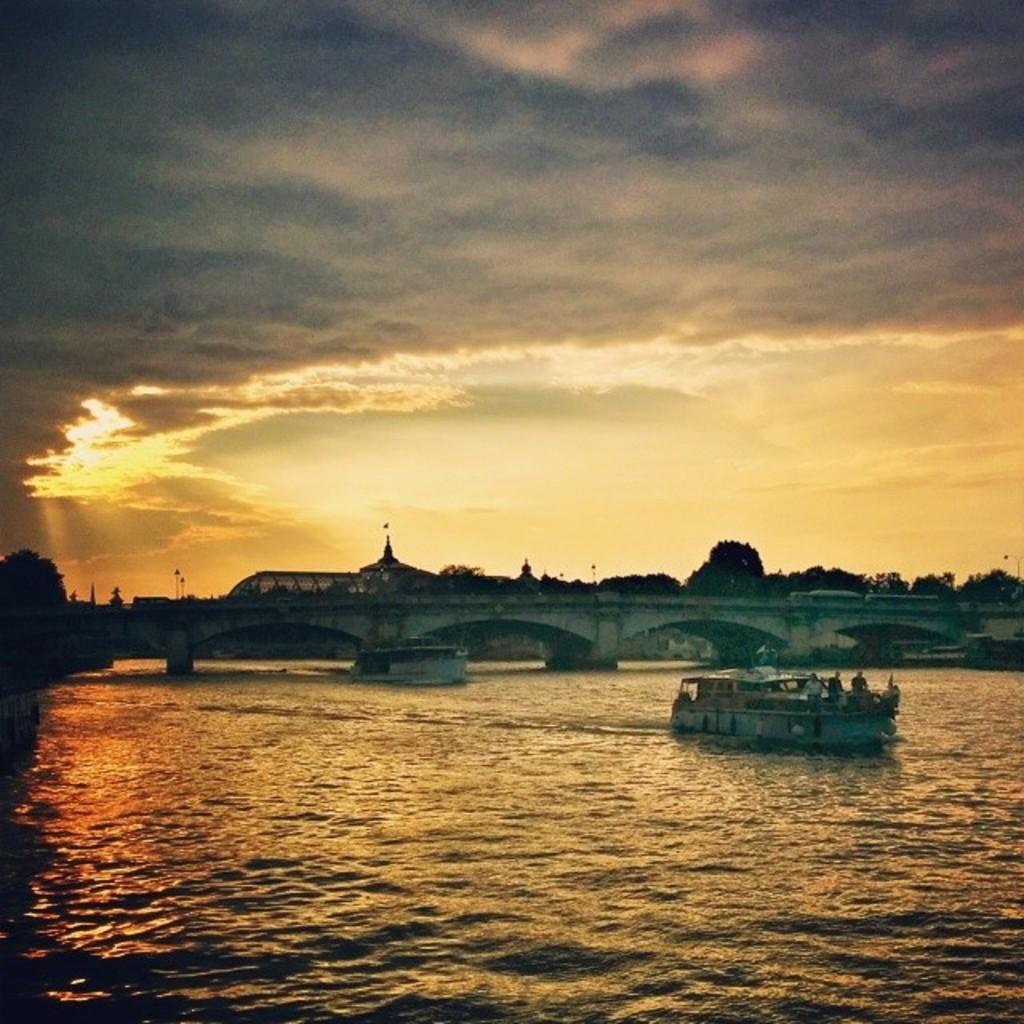In one or two sentences, can you explain what this image depicts? In this image there is a river and we can see boats on the river. In the background there is a bridge, trees and sky. 